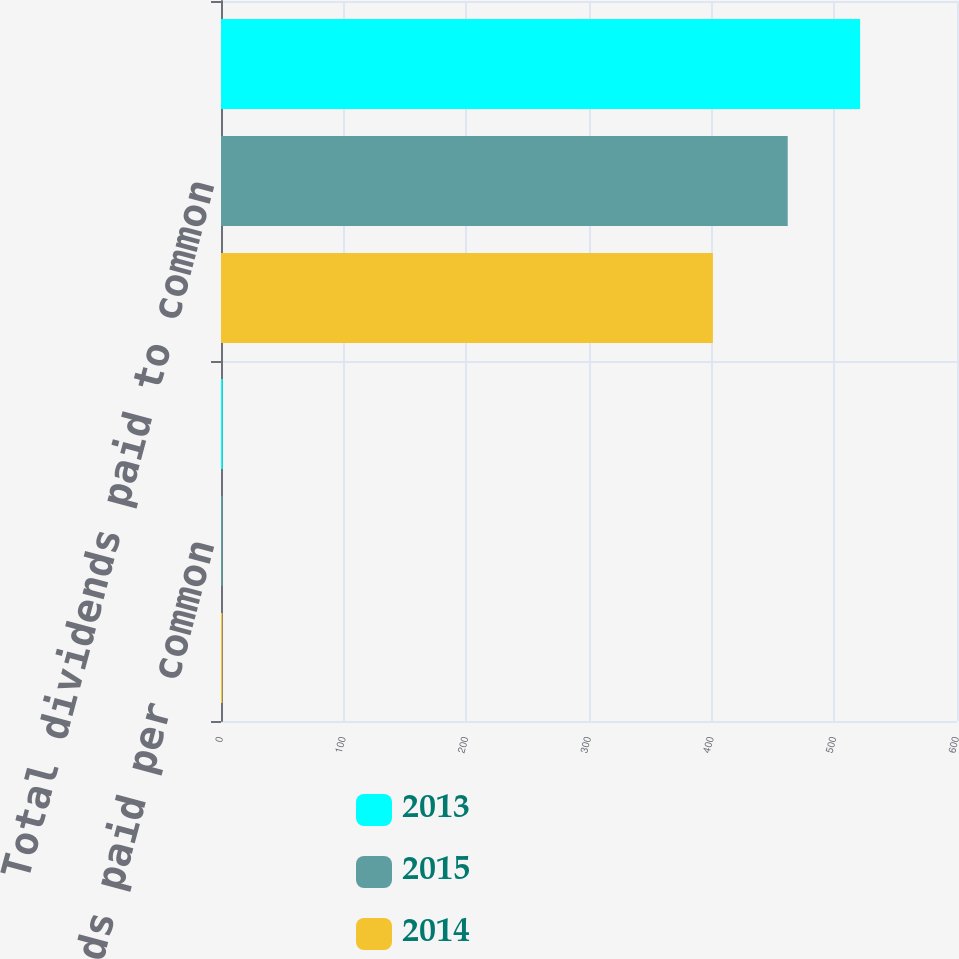Convert chart. <chart><loc_0><loc_0><loc_500><loc_500><stacked_bar_chart><ecel><fcel>Dividends paid per common<fcel>Total dividends paid to common<nl><fcel>2013<fcel>1.34<fcel>521<nl><fcel>2015<fcel>1.22<fcel>462<nl><fcel>2014<fcel>1.06<fcel>401<nl></chart> 